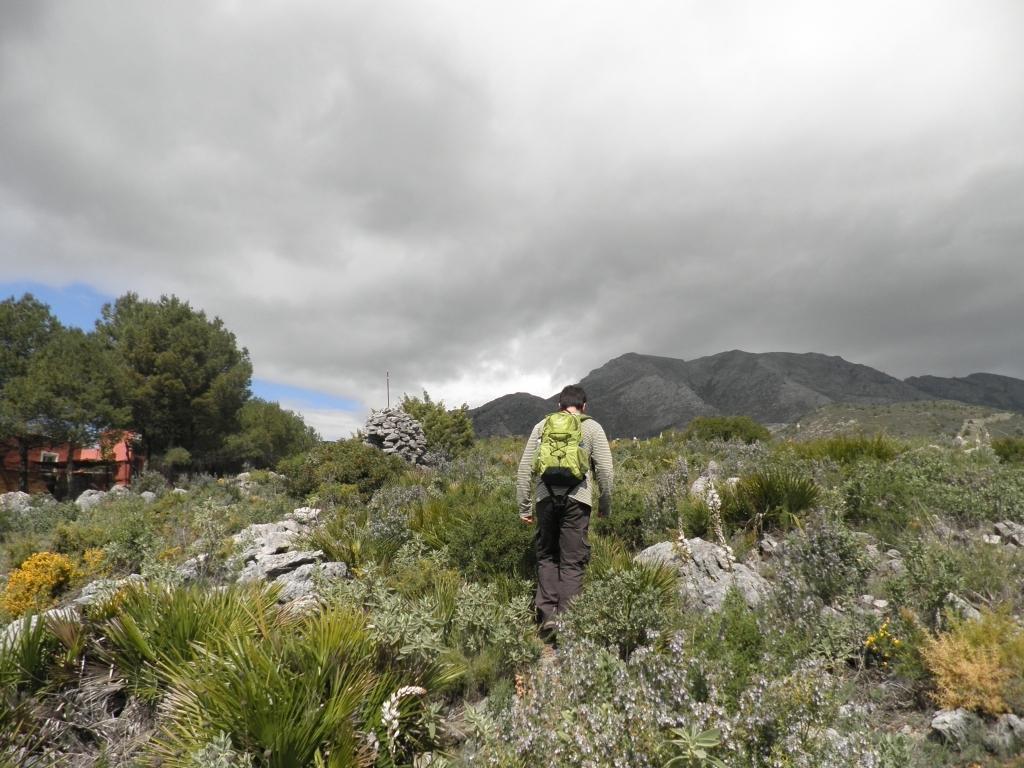Could you give a brief overview of what you see in this image? In this image there is a man walking on the ground. On the ground there are small plants and stones. In front of him there are hills. On the left side there are trees under which there is a house. At the top there is sky with the clouds. 